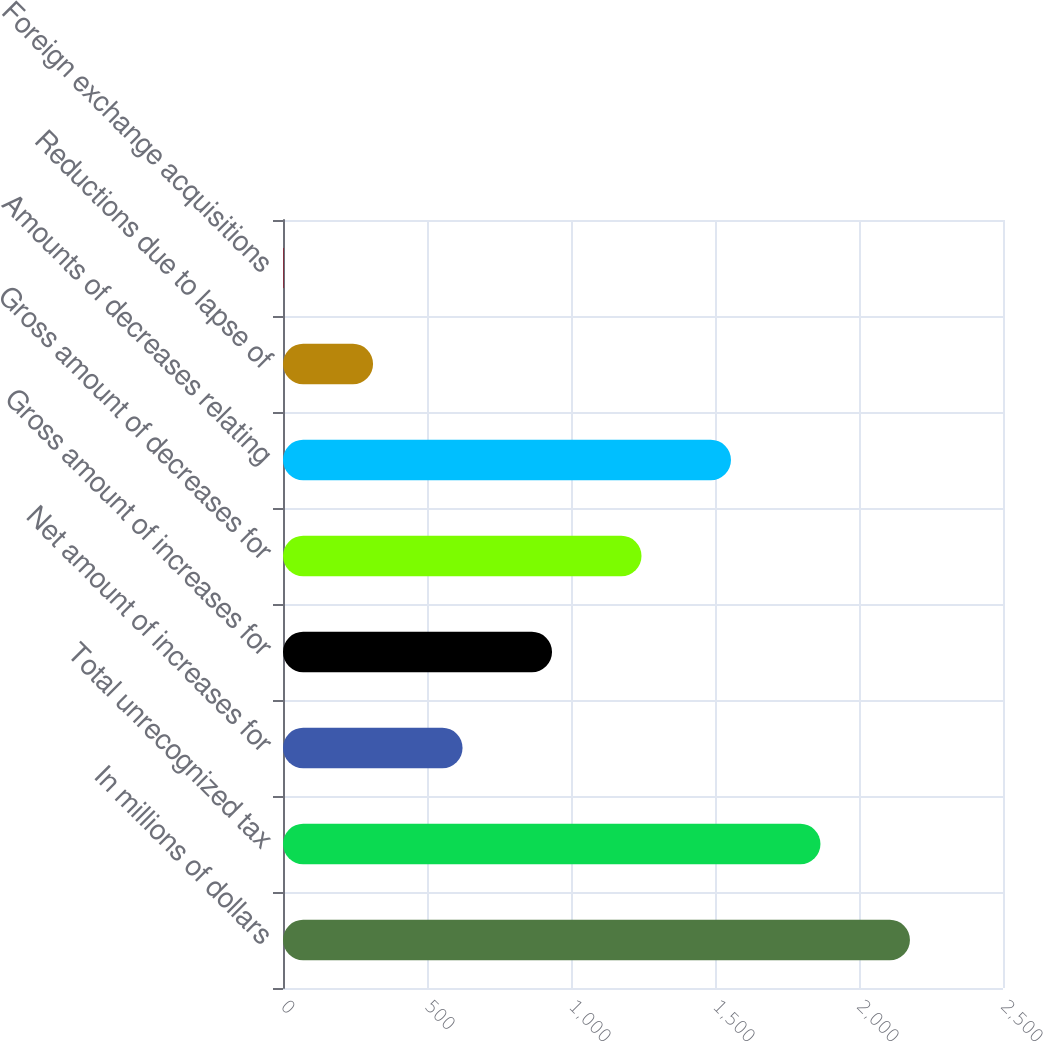<chart> <loc_0><loc_0><loc_500><loc_500><bar_chart><fcel>In millions of dollars<fcel>Total unrecognized tax<fcel>Net amount of increases for<fcel>Gross amount of increases for<fcel>Gross amount of decreases for<fcel>Amounts of decreases relating<fcel>Reductions due to lapse of<fcel>Foreign exchange acquisitions<nl><fcel>2176.9<fcel>1866.2<fcel>623.4<fcel>934.1<fcel>1244.8<fcel>1555.5<fcel>312.7<fcel>2<nl></chart> 